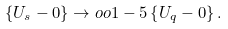Convert formula to latex. <formula><loc_0><loc_0><loc_500><loc_500>\left \{ U _ { s } - 0 \right \} \to o o { 1 - 5 } \left \{ U _ { q } - 0 \right \} .</formula> 